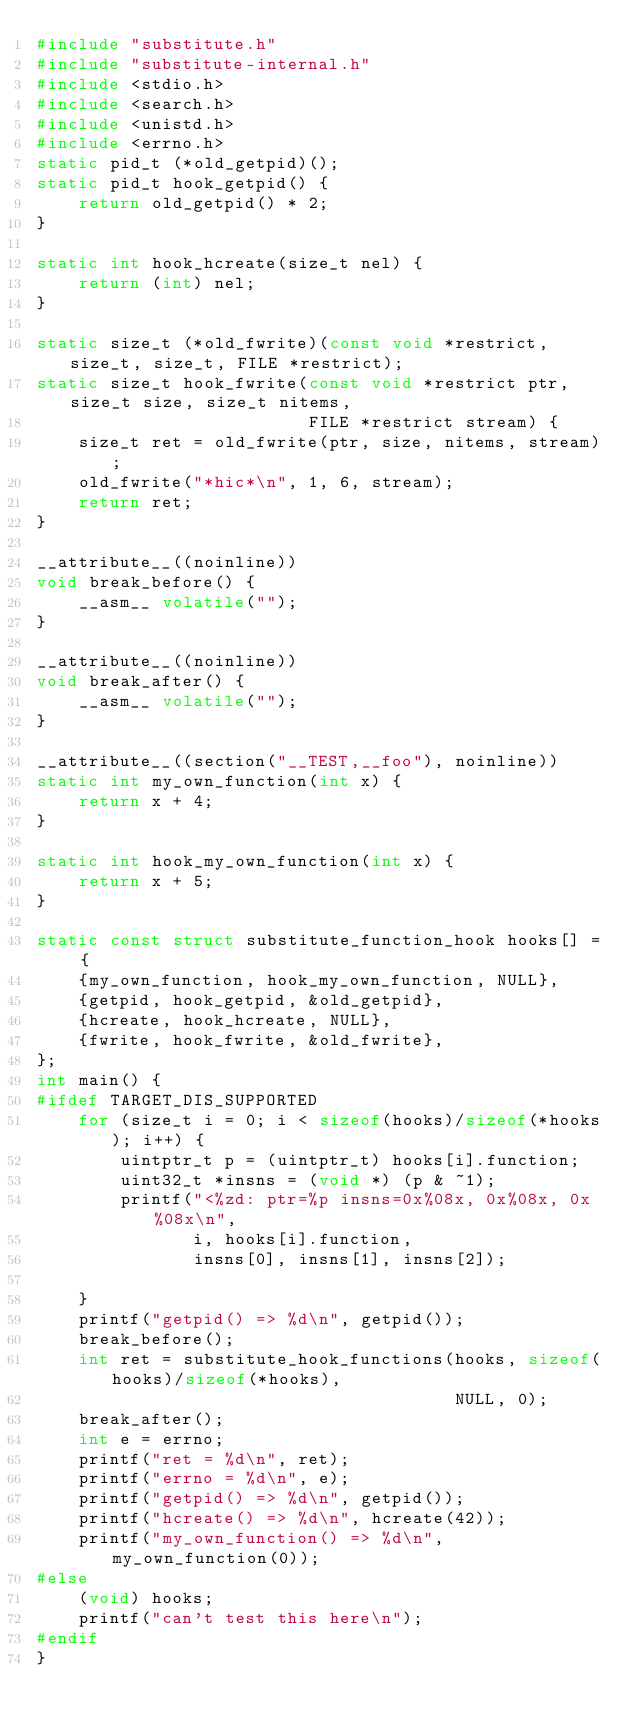<code> <loc_0><loc_0><loc_500><loc_500><_C_>#include "substitute.h"
#include "substitute-internal.h"
#include <stdio.h>
#include <search.h>
#include <unistd.h>
#include <errno.h>
static pid_t (*old_getpid)();
static pid_t hook_getpid() {
    return old_getpid() * 2;
}

static int hook_hcreate(size_t nel) {
    return (int) nel;
}

static size_t (*old_fwrite)(const void *restrict, size_t, size_t, FILE *restrict);
static size_t hook_fwrite(const void *restrict ptr, size_t size, size_t nitems,
                          FILE *restrict stream) {
    size_t ret = old_fwrite(ptr, size, nitems, stream);
    old_fwrite("*hic*\n", 1, 6, stream);
    return ret;
}

__attribute__((noinline))
void break_before() {
    __asm__ volatile("");
}

__attribute__((noinline))
void break_after() {
    __asm__ volatile("");
}

__attribute__((section("__TEST,__foo"), noinline))
static int my_own_function(int x) {
    return x + 4;
}

static int hook_my_own_function(int x) {
    return x + 5;
}

static const struct substitute_function_hook hooks[] = {
    {my_own_function, hook_my_own_function, NULL},
    {getpid, hook_getpid, &old_getpid},
    {hcreate, hook_hcreate, NULL},
    {fwrite, hook_fwrite, &old_fwrite},
};
int main() {
#ifdef TARGET_DIS_SUPPORTED
    for (size_t i = 0; i < sizeof(hooks)/sizeof(*hooks); i++) {
        uintptr_t p = (uintptr_t) hooks[i].function;
        uint32_t *insns = (void *) (p & ~1);
        printf("<%zd: ptr=%p insns=0x%08x, 0x%08x, 0x%08x\n",
               i, hooks[i].function,
               insns[0], insns[1], insns[2]);

    }
    printf("getpid() => %d\n", getpid());
    break_before();
    int ret = substitute_hook_functions(hooks, sizeof(hooks)/sizeof(*hooks),
                                        NULL, 0);
    break_after();
    int e = errno;
    printf("ret = %d\n", ret);
    printf("errno = %d\n", e);
    printf("getpid() => %d\n", getpid());
    printf("hcreate() => %d\n", hcreate(42));
    printf("my_own_function() => %d\n", my_own_function(0));
#else
    (void) hooks;
    printf("can't test this here\n");
#endif
}
</code> 